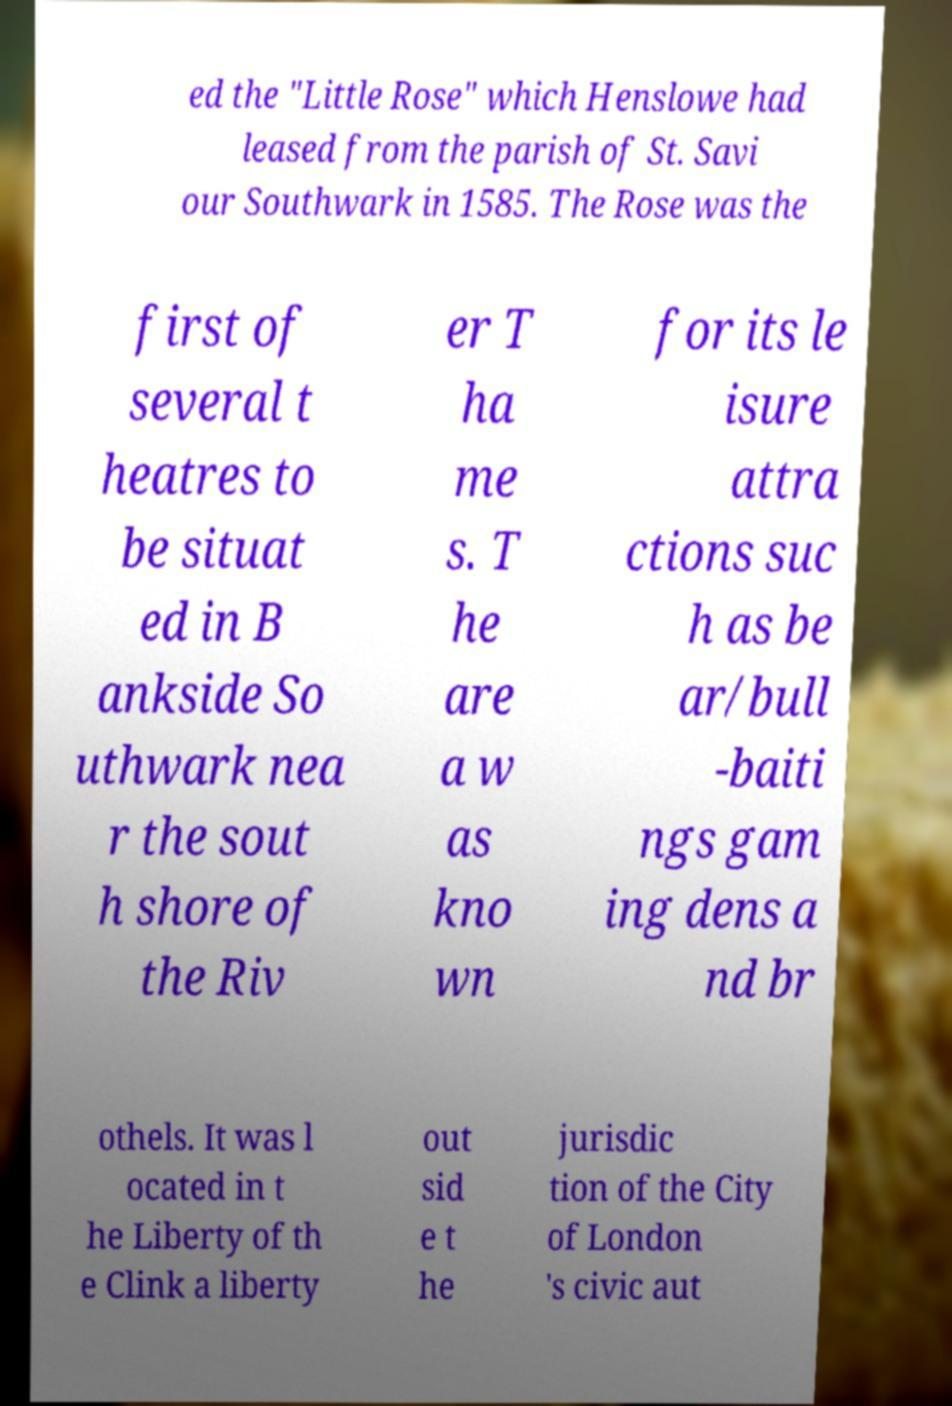Can you read and provide the text displayed in the image?This photo seems to have some interesting text. Can you extract and type it out for me? ed the "Little Rose" which Henslowe had leased from the parish of St. Savi our Southwark in 1585. The Rose was the first of several t heatres to be situat ed in B ankside So uthwark nea r the sout h shore of the Riv er T ha me s. T he are a w as kno wn for its le isure attra ctions suc h as be ar/bull -baiti ngs gam ing dens a nd br othels. It was l ocated in t he Liberty of th e Clink a liberty out sid e t he jurisdic tion of the City of London 's civic aut 